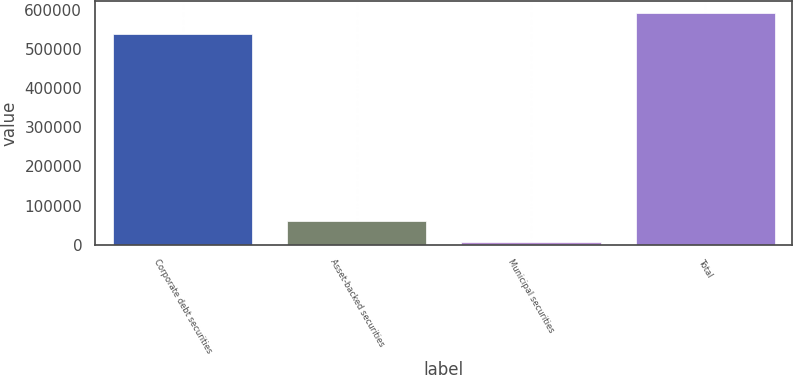<chart> <loc_0><loc_0><loc_500><loc_500><bar_chart><fcel>Corporate debt securities<fcel>Asset-backed securities<fcel>Municipal securities<fcel>Total<nl><fcel>538109<fcel>61079.5<fcel>6599<fcel>592590<nl></chart> 